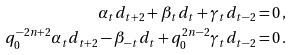Convert formula to latex. <formula><loc_0><loc_0><loc_500><loc_500>\alpha _ { t } d _ { t + 2 } + \beta _ { t } d _ { t } + \gamma _ { t } d _ { t - 2 } = & \, 0 \, , \\ q _ { 0 } ^ { - 2 n + 2 } \alpha _ { t } d _ { t + 2 } - \beta _ { - t } d _ { t } + q _ { 0 } ^ { 2 n - 2 } \gamma _ { t } d _ { t - 2 } = & \, 0 \, .</formula> 